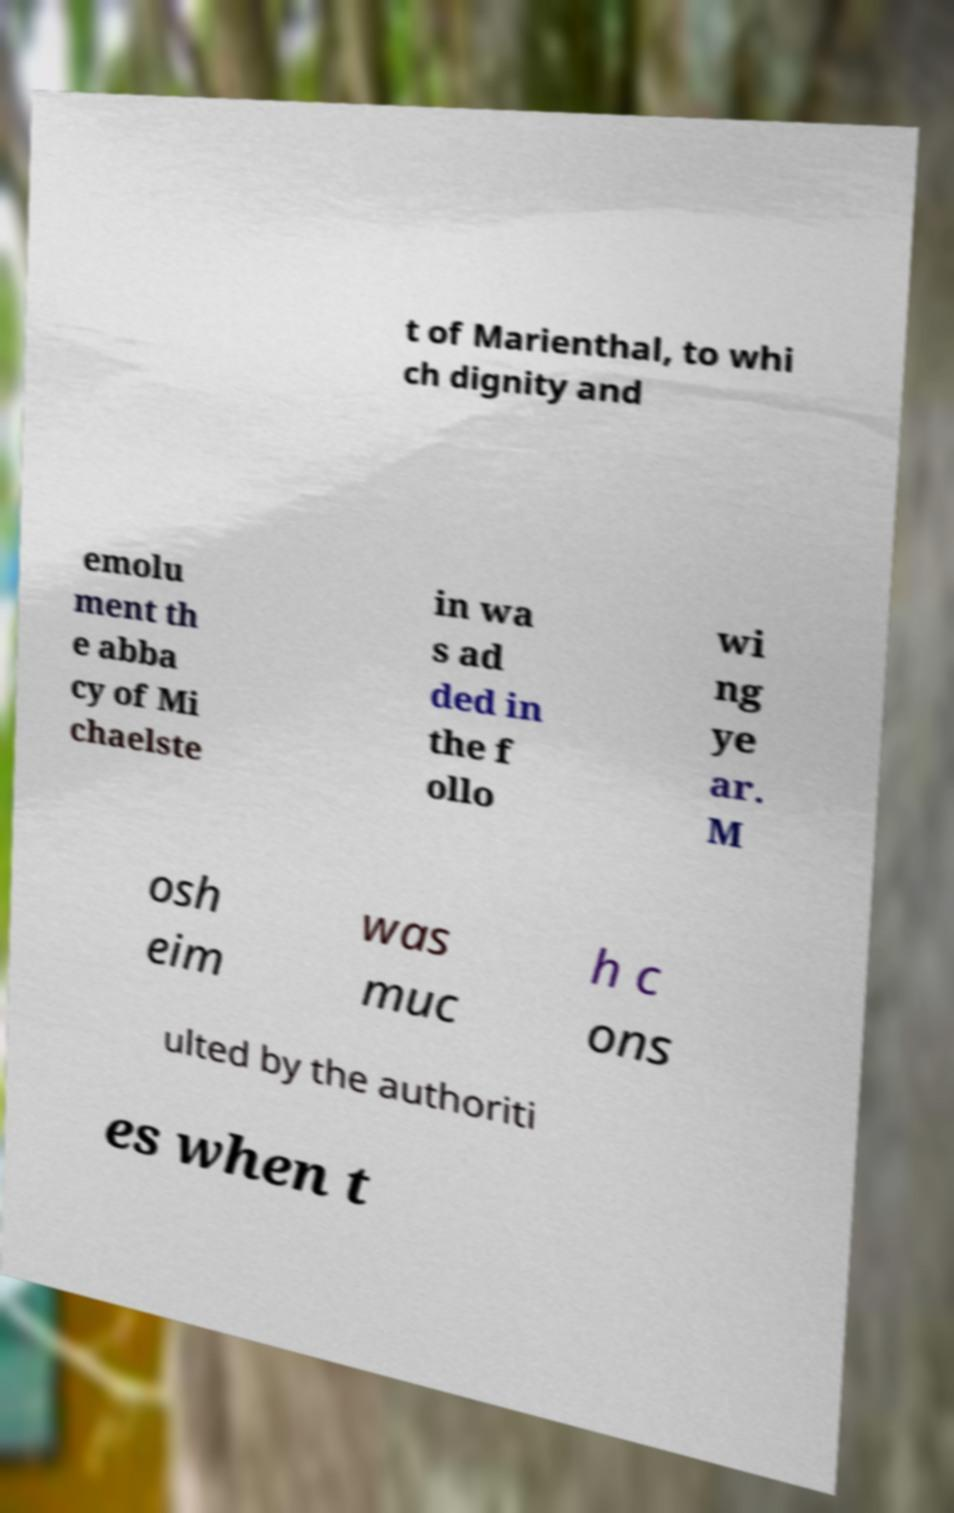Could you assist in decoding the text presented in this image and type it out clearly? t of Marienthal, to whi ch dignity and emolu ment th e abba cy of Mi chaelste in wa s ad ded in the f ollo wi ng ye ar. M osh eim was muc h c ons ulted by the authoriti es when t 